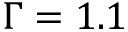<formula> <loc_0><loc_0><loc_500><loc_500>\Gamma = 1 . 1</formula> 